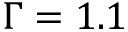<formula> <loc_0><loc_0><loc_500><loc_500>\Gamma = 1 . 1</formula> 